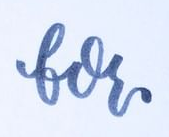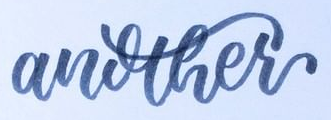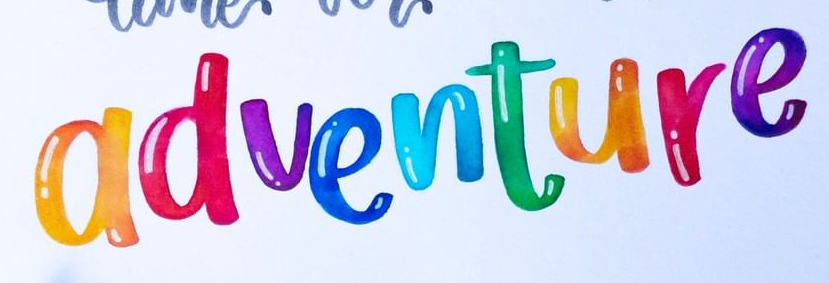What words can you see in these images in sequence, separated by a semicolon? for; another; adventure 